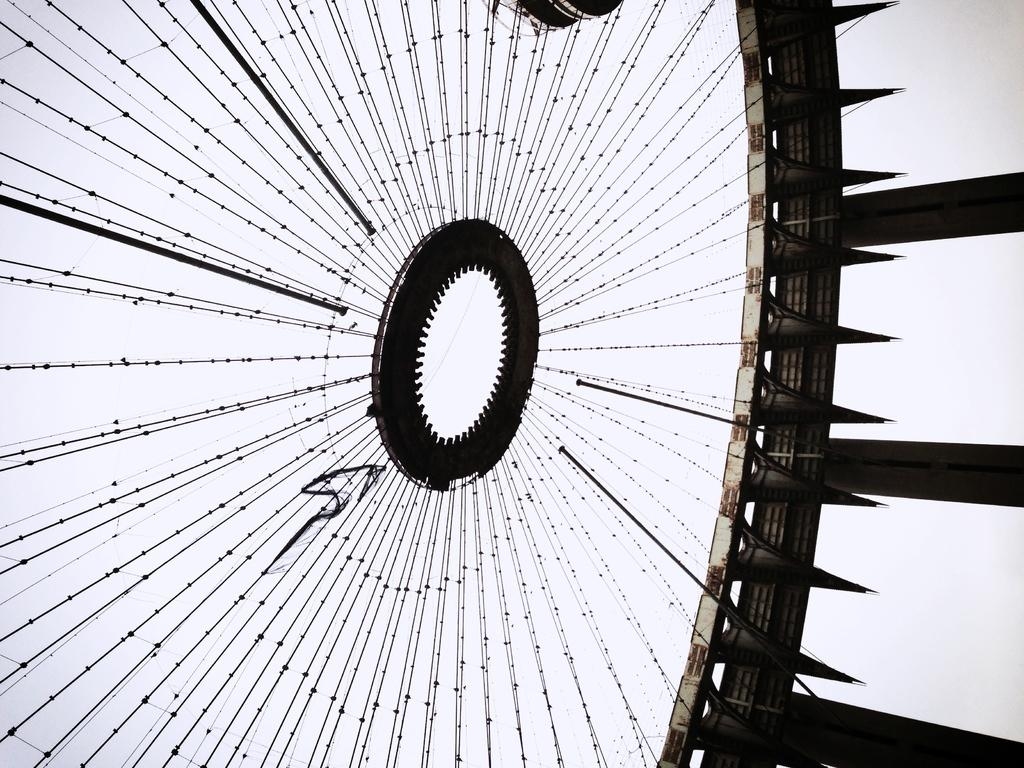What type of objects are present in the image? There are cables and metal rods in the image. Can you describe the cables in the image? The cables in the image are long, flexible, and typically used for transmitting signals or power. What is the material of the rods in the image? The rods in the image are made of metal. Can you see any bananas hanging from the cables in the image? There are no bananas present in the image. What type of print can be seen on the metal rods in the image? There is no print visible on the metal rods in the image. Is there a snail crawling on the cables in the image? There is no snail present in the image. 